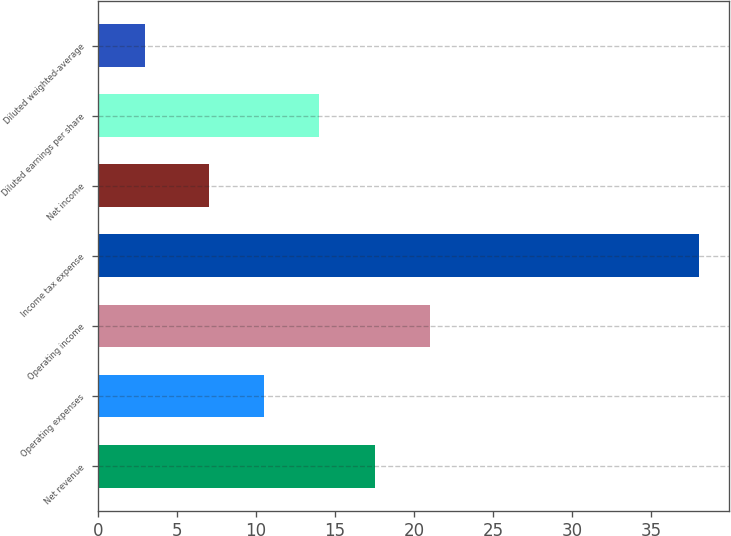Convert chart to OTSL. <chart><loc_0><loc_0><loc_500><loc_500><bar_chart><fcel>Net revenue<fcel>Operating expenses<fcel>Operating income<fcel>Income tax expense<fcel>Net income<fcel>Diluted earnings per share<fcel>Diluted weighted-average<nl><fcel>17.5<fcel>10.5<fcel>21<fcel>38<fcel>7<fcel>14<fcel>3<nl></chart> 